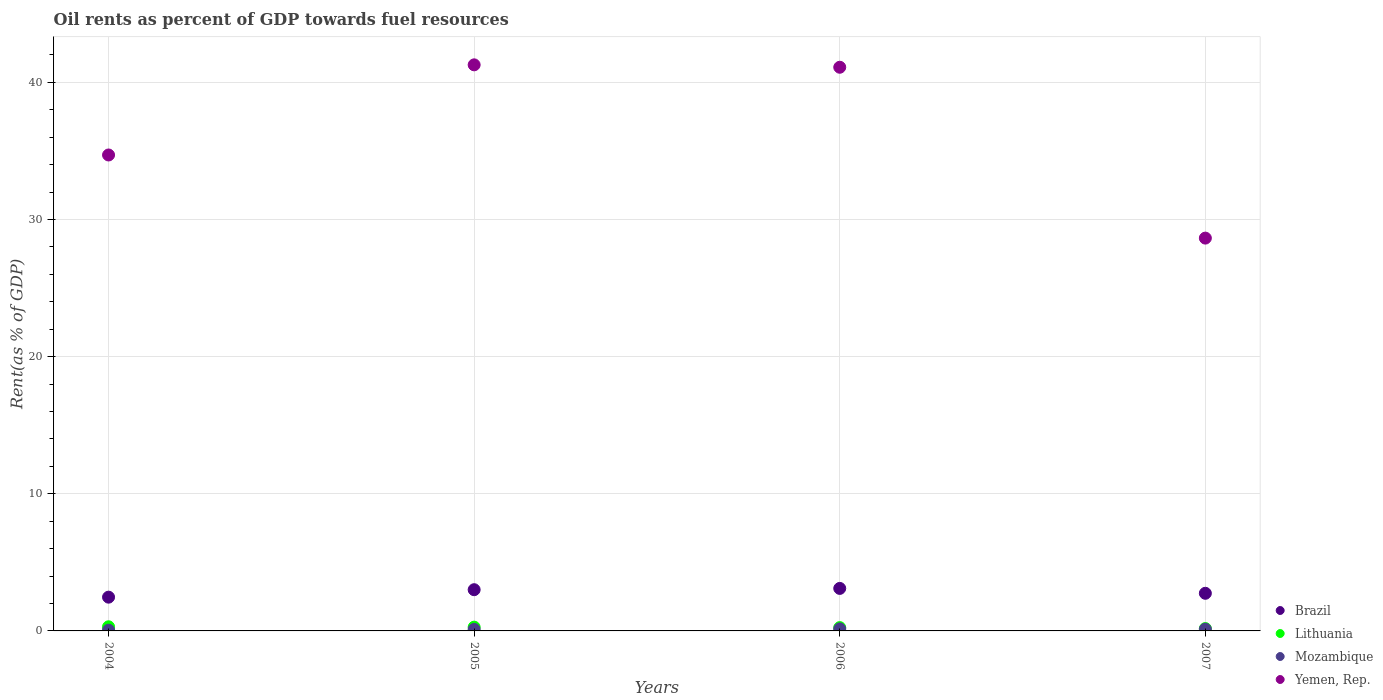How many different coloured dotlines are there?
Offer a terse response. 4. What is the oil rent in Mozambique in 2005?
Your answer should be compact. 0.11. Across all years, what is the maximum oil rent in Lithuania?
Offer a terse response. 0.3. Across all years, what is the minimum oil rent in Brazil?
Give a very brief answer. 2.46. In which year was the oil rent in Lithuania minimum?
Offer a very short reply. 2007. What is the total oil rent in Yemen, Rep. in the graph?
Offer a terse response. 145.74. What is the difference between the oil rent in Lithuania in 2006 and that in 2007?
Provide a short and direct response. 0.07. What is the difference between the oil rent in Mozambique in 2004 and the oil rent in Lithuania in 2007?
Give a very brief answer. -0.12. What is the average oil rent in Brazil per year?
Keep it short and to the point. 2.83. In the year 2005, what is the difference between the oil rent in Lithuania and oil rent in Brazil?
Your answer should be very brief. -2.73. In how many years, is the oil rent in Yemen, Rep. greater than 30 %?
Your answer should be very brief. 3. What is the ratio of the oil rent in Yemen, Rep. in 2005 to that in 2007?
Offer a terse response. 1.44. Is the oil rent in Lithuania in 2005 less than that in 2007?
Keep it short and to the point. No. Is the difference between the oil rent in Lithuania in 2005 and 2006 greater than the difference between the oil rent in Brazil in 2005 and 2006?
Offer a very short reply. Yes. What is the difference between the highest and the second highest oil rent in Brazil?
Keep it short and to the point. 0.09. What is the difference between the highest and the lowest oil rent in Lithuania?
Your response must be concise. 0.13. Does the oil rent in Lithuania monotonically increase over the years?
Provide a succinct answer. No. Is the oil rent in Mozambique strictly greater than the oil rent in Yemen, Rep. over the years?
Offer a terse response. No. Is the oil rent in Yemen, Rep. strictly less than the oil rent in Mozambique over the years?
Provide a short and direct response. No. What is the difference between two consecutive major ticks on the Y-axis?
Give a very brief answer. 10. Are the values on the major ticks of Y-axis written in scientific E-notation?
Offer a very short reply. No. Does the graph contain grids?
Your response must be concise. Yes. How many legend labels are there?
Offer a terse response. 4. What is the title of the graph?
Offer a very short reply. Oil rents as percent of GDP towards fuel resources. What is the label or title of the X-axis?
Make the answer very short. Years. What is the label or title of the Y-axis?
Your answer should be compact. Rent(as % of GDP). What is the Rent(as % of GDP) of Brazil in 2004?
Provide a succinct answer. 2.46. What is the Rent(as % of GDP) of Lithuania in 2004?
Your answer should be very brief. 0.3. What is the Rent(as % of GDP) of Mozambique in 2004?
Offer a very short reply. 0.05. What is the Rent(as % of GDP) in Yemen, Rep. in 2004?
Ensure brevity in your answer.  34.71. What is the Rent(as % of GDP) of Brazil in 2005?
Your response must be concise. 3.01. What is the Rent(as % of GDP) of Lithuania in 2005?
Keep it short and to the point. 0.28. What is the Rent(as % of GDP) in Mozambique in 2005?
Offer a terse response. 0.11. What is the Rent(as % of GDP) of Yemen, Rep. in 2005?
Ensure brevity in your answer.  41.28. What is the Rent(as % of GDP) of Brazil in 2006?
Offer a very short reply. 3.1. What is the Rent(as % of GDP) of Lithuania in 2006?
Offer a terse response. 0.24. What is the Rent(as % of GDP) in Mozambique in 2006?
Your answer should be compact. 0.15. What is the Rent(as % of GDP) in Yemen, Rep. in 2006?
Your response must be concise. 41.1. What is the Rent(as % of GDP) of Brazil in 2007?
Keep it short and to the point. 2.74. What is the Rent(as % of GDP) of Lithuania in 2007?
Make the answer very short. 0.17. What is the Rent(as % of GDP) in Mozambique in 2007?
Offer a very short reply. 0.13. What is the Rent(as % of GDP) in Yemen, Rep. in 2007?
Offer a very short reply. 28.65. Across all years, what is the maximum Rent(as % of GDP) of Brazil?
Provide a short and direct response. 3.1. Across all years, what is the maximum Rent(as % of GDP) in Lithuania?
Offer a terse response. 0.3. Across all years, what is the maximum Rent(as % of GDP) of Mozambique?
Give a very brief answer. 0.15. Across all years, what is the maximum Rent(as % of GDP) in Yemen, Rep.?
Give a very brief answer. 41.28. Across all years, what is the minimum Rent(as % of GDP) of Brazil?
Make the answer very short. 2.46. Across all years, what is the minimum Rent(as % of GDP) in Lithuania?
Your answer should be compact. 0.17. Across all years, what is the minimum Rent(as % of GDP) of Mozambique?
Provide a succinct answer. 0.05. Across all years, what is the minimum Rent(as % of GDP) of Yemen, Rep.?
Provide a short and direct response. 28.65. What is the total Rent(as % of GDP) of Brazil in the graph?
Ensure brevity in your answer.  11.31. What is the total Rent(as % of GDP) of Mozambique in the graph?
Your response must be concise. 0.44. What is the total Rent(as % of GDP) in Yemen, Rep. in the graph?
Offer a terse response. 145.74. What is the difference between the Rent(as % of GDP) of Brazil in 2004 and that in 2005?
Your answer should be compact. -0.54. What is the difference between the Rent(as % of GDP) in Lithuania in 2004 and that in 2005?
Give a very brief answer. 0.03. What is the difference between the Rent(as % of GDP) of Mozambique in 2004 and that in 2005?
Provide a succinct answer. -0.06. What is the difference between the Rent(as % of GDP) in Yemen, Rep. in 2004 and that in 2005?
Your answer should be compact. -6.57. What is the difference between the Rent(as % of GDP) in Brazil in 2004 and that in 2006?
Your answer should be compact. -0.64. What is the difference between the Rent(as % of GDP) of Lithuania in 2004 and that in 2006?
Your response must be concise. 0.06. What is the difference between the Rent(as % of GDP) in Mozambique in 2004 and that in 2006?
Your answer should be compact. -0.09. What is the difference between the Rent(as % of GDP) in Yemen, Rep. in 2004 and that in 2006?
Ensure brevity in your answer.  -6.4. What is the difference between the Rent(as % of GDP) in Brazil in 2004 and that in 2007?
Keep it short and to the point. -0.28. What is the difference between the Rent(as % of GDP) in Lithuania in 2004 and that in 2007?
Your answer should be compact. 0.13. What is the difference between the Rent(as % of GDP) in Mozambique in 2004 and that in 2007?
Your answer should be compact. -0.07. What is the difference between the Rent(as % of GDP) in Yemen, Rep. in 2004 and that in 2007?
Keep it short and to the point. 6.06. What is the difference between the Rent(as % of GDP) in Brazil in 2005 and that in 2006?
Give a very brief answer. -0.09. What is the difference between the Rent(as % of GDP) in Lithuania in 2005 and that in 2006?
Make the answer very short. 0.03. What is the difference between the Rent(as % of GDP) of Mozambique in 2005 and that in 2006?
Give a very brief answer. -0.04. What is the difference between the Rent(as % of GDP) of Yemen, Rep. in 2005 and that in 2006?
Your answer should be very brief. 0.18. What is the difference between the Rent(as % of GDP) of Brazil in 2005 and that in 2007?
Offer a terse response. 0.26. What is the difference between the Rent(as % of GDP) of Lithuania in 2005 and that in 2007?
Offer a terse response. 0.1. What is the difference between the Rent(as % of GDP) in Mozambique in 2005 and that in 2007?
Keep it short and to the point. -0.02. What is the difference between the Rent(as % of GDP) in Yemen, Rep. in 2005 and that in 2007?
Give a very brief answer. 12.64. What is the difference between the Rent(as % of GDP) of Brazil in 2006 and that in 2007?
Offer a very short reply. 0.36. What is the difference between the Rent(as % of GDP) in Lithuania in 2006 and that in 2007?
Ensure brevity in your answer.  0.07. What is the difference between the Rent(as % of GDP) in Mozambique in 2006 and that in 2007?
Give a very brief answer. 0.02. What is the difference between the Rent(as % of GDP) of Yemen, Rep. in 2006 and that in 2007?
Provide a succinct answer. 12.46. What is the difference between the Rent(as % of GDP) in Brazil in 2004 and the Rent(as % of GDP) in Lithuania in 2005?
Offer a very short reply. 2.19. What is the difference between the Rent(as % of GDP) in Brazil in 2004 and the Rent(as % of GDP) in Mozambique in 2005?
Your answer should be compact. 2.35. What is the difference between the Rent(as % of GDP) of Brazil in 2004 and the Rent(as % of GDP) of Yemen, Rep. in 2005?
Your answer should be very brief. -38.82. What is the difference between the Rent(as % of GDP) in Lithuania in 2004 and the Rent(as % of GDP) in Mozambique in 2005?
Provide a short and direct response. 0.19. What is the difference between the Rent(as % of GDP) in Lithuania in 2004 and the Rent(as % of GDP) in Yemen, Rep. in 2005?
Your response must be concise. -40.98. What is the difference between the Rent(as % of GDP) in Mozambique in 2004 and the Rent(as % of GDP) in Yemen, Rep. in 2005?
Give a very brief answer. -41.23. What is the difference between the Rent(as % of GDP) of Brazil in 2004 and the Rent(as % of GDP) of Lithuania in 2006?
Your answer should be very brief. 2.22. What is the difference between the Rent(as % of GDP) in Brazil in 2004 and the Rent(as % of GDP) in Mozambique in 2006?
Your answer should be very brief. 2.31. What is the difference between the Rent(as % of GDP) in Brazil in 2004 and the Rent(as % of GDP) in Yemen, Rep. in 2006?
Your answer should be very brief. -38.64. What is the difference between the Rent(as % of GDP) in Lithuania in 2004 and the Rent(as % of GDP) in Mozambique in 2006?
Provide a succinct answer. 0.15. What is the difference between the Rent(as % of GDP) in Lithuania in 2004 and the Rent(as % of GDP) in Yemen, Rep. in 2006?
Your answer should be compact. -40.8. What is the difference between the Rent(as % of GDP) in Mozambique in 2004 and the Rent(as % of GDP) in Yemen, Rep. in 2006?
Offer a very short reply. -41.05. What is the difference between the Rent(as % of GDP) in Brazil in 2004 and the Rent(as % of GDP) in Lithuania in 2007?
Make the answer very short. 2.29. What is the difference between the Rent(as % of GDP) in Brazil in 2004 and the Rent(as % of GDP) in Mozambique in 2007?
Your response must be concise. 2.34. What is the difference between the Rent(as % of GDP) in Brazil in 2004 and the Rent(as % of GDP) in Yemen, Rep. in 2007?
Your response must be concise. -26.18. What is the difference between the Rent(as % of GDP) of Lithuania in 2004 and the Rent(as % of GDP) of Mozambique in 2007?
Offer a terse response. 0.18. What is the difference between the Rent(as % of GDP) of Lithuania in 2004 and the Rent(as % of GDP) of Yemen, Rep. in 2007?
Make the answer very short. -28.34. What is the difference between the Rent(as % of GDP) in Mozambique in 2004 and the Rent(as % of GDP) in Yemen, Rep. in 2007?
Make the answer very short. -28.59. What is the difference between the Rent(as % of GDP) in Brazil in 2005 and the Rent(as % of GDP) in Lithuania in 2006?
Keep it short and to the point. 2.76. What is the difference between the Rent(as % of GDP) of Brazil in 2005 and the Rent(as % of GDP) of Mozambique in 2006?
Give a very brief answer. 2.86. What is the difference between the Rent(as % of GDP) in Brazil in 2005 and the Rent(as % of GDP) in Yemen, Rep. in 2006?
Provide a short and direct response. -38.1. What is the difference between the Rent(as % of GDP) in Lithuania in 2005 and the Rent(as % of GDP) in Mozambique in 2006?
Ensure brevity in your answer.  0.13. What is the difference between the Rent(as % of GDP) in Lithuania in 2005 and the Rent(as % of GDP) in Yemen, Rep. in 2006?
Provide a succinct answer. -40.83. What is the difference between the Rent(as % of GDP) in Mozambique in 2005 and the Rent(as % of GDP) in Yemen, Rep. in 2006?
Keep it short and to the point. -40.99. What is the difference between the Rent(as % of GDP) in Brazil in 2005 and the Rent(as % of GDP) in Lithuania in 2007?
Your answer should be compact. 2.83. What is the difference between the Rent(as % of GDP) in Brazil in 2005 and the Rent(as % of GDP) in Mozambique in 2007?
Your answer should be compact. 2.88. What is the difference between the Rent(as % of GDP) of Brazil in 2005 and the Rent(as % of GDP) of Yemen, Rep. in 2007?
Offer a terse response. -25.64. What is the difference between the Rent(as % of GDP) of Lithuania in 2005 and the Rent(as % of GDP) of Mozambique in 2007?
Your answer should be compact. 0.15. What is the difference between the Rent(as % of GDP) of Lithuania in 2005 and the Rent(as % of GDP) of Yemen, Rep. in 2007?
Your response must be concise. -28.37. What is the difference between the Rent(as % of GDP) in Mozambique in 2005 and the Rent(as % of GDP) in Yemen, Rep. in 2007?
Keep it short and to the point. -28.53. What is the difference between the Rent(as % of GDP) in Brazil in 2006 and the Rent(as % of GDP) in Lithuania in 2007?
Keep it short and to the point. 2.93. What is the difference between the Rent(as % of GDP) of Brazil in 2006 and the Rent(as % of GDP) of Mozambique in 2007?
Make the answer very short. 2.97. What is the difference between the Rent(as % of GDP) of Brazil in 2006 and the Rent(as % of GDP) of Yemen, Rep. in 2007?
Your answer should be very brief. -25.55. What is the difference between the Rent(as % of GDP) of Lithuania in 2006 and the Rent(as % of GDP) of Mozambique in 2007?
Make the answer very short. 0.12. What is the difference between the Rent(as % of GDP) of Lithuania in 2006 and the Rent(as % of GDP) of Yemen, Rep. in 2007?
Your answer should be compact. -28.4. What is the difference between the Rent(as % of GDP) in Mozambique in 2006 and the Rent(as % of GDP) in Yemen, Rep. in 2007?
Make the answer very short. -28.5. What is the average Rent(as % of GDP) of Brazil per year?
Offer a very short reply. 2.83. What is the average Rent(as % of GDP) of Lithuania per year?
Provide a short and direct response. 0.25. What is the average Rent(as % of GDP) in Mozambique per year?
Offer a terse response. 0.11. What is the average Rent(as % of GDP) in Yemen, Rep. per year?
Ensure brevity in your answer.  36.43. In the year 2004, what is the difference between the Rent(as % of GDP) in Brazil and Rent(as % of GDP) in Lithuania?
Provide a short and direct response. 2.16. In the year 2004, what is the difference between the Rent(as % of GDP) of Brazil and Rent(as % of GDP) of Mozambique?
Offer a terse response. 2.41. In the year 2004, what is the difference between the Rent(as % of GDP) in Brazil and Rent(as % of GDP) in Yemen, Rep.?
Provide a short and direct response. -32.24. In the year 2004, what is the difference between the Rent(as % of GDP) in Lithuania and Rent(as % of GDP) in Mozambique?
Ensure brevity in your answer.  0.25. In the year 2004, what is the difference between the Rent(as % of GDP) of Lithuania and Rent(as % of GDP) of Yemen, Rep.?
Keep it short and to the point. -34.4. In the year 2004, what is the difference between the Rent(as % of GDP) of Mozambique and Rent(as % of GDP) of Yemen, Rep.?
Your response must be concise. -34.65. In the year 2005, what is the difference between the Rent(as % of GDP) in Brazil and Rent(as % of GDP) in Lithuania?
Provide a succinct answer. 2.73. In the year 2005, what is the difference between the Rent(as % of GDP) in Brazil and Rent(as % of GDP) in Mozambique?
Your answer should be very brief. 2.9. In the year 2005, what is the difference between the Rent(as % of GDP) in Brazil and Rent(as % of GDP) in Yemen, Rep.?
Your answer should be very brief. -38.27. In the year 2005, what is the difference between the Rent(as % of GDP) in Lithuania and Rent(as % of GDP) in Mozambique?
Make the answer very short. 0.16. In the year 2005, what is the difference between the Rent(as % of GDP) of Lithuania and Rent(as % of GDP) of Yemen, Rep.?
Provide a succinct answer. -41.01. In the year 2005, what is the difference between the Rent(as % of GDP) in Mozambique and Rent(as % of GDP) in Yemen, Rep.?
Your response must be concise. -41.17. In the year 2006, what is the difference between the Rent(as % of GDP) of Brazil and Rent(as % of GDP) of Lithuania?
Your answer should be very brief. 2.86. In the year 2006, what is the difference between the Rent(as % of GDP) of Brazil and Rent(as % of GDP) of Mozambique?
Your response must be concise. 2.95. In the year 2006, what is the difference between the Rent(as % of GDP) in Brazil and Rent(as % of GDP) in Yemen, Rep.?
Keep it short and to the point. -38. In the year 2006, what is the difference between the Rent(as % of GDP) of Lithuania and Rent(as % of GDP) of Mozambique?
Provide a succinct answer. 0.09. In the year 2006, what is the difference between the Rent(as % of GDP) of Lithuania and Rent(as % of GDP) of Yemen, Rep.?
Keep it short and to the point. -40.86. In the year 2006, what is the difference between the Rent(as % of GDP) in Mozambique and Rent(as % of GDP) in Yemen, Rep.?
Provide a short and direct response. -40.96. In the year 2007, what is the difference between the Rent(as % of GDP) in Brazil and Rent(as % of GDP) in Lithuania?
Provide a succinct answer. 2.57. In the year 2007, what is the difference between the Rent(as % of GDP) in Brazil and Rent(as % of GDP) in Mozambique?
Your answer should be compact. 2.62. In the year 2007, what is the difference between the Rent(as % of GDP) of Brazil and Rent(as % of GDP) of Yemen, Rep.?
Give a very brief answer. -25.9. In the year 2007, what is the difference between the Rent(as % of GDP) of Lithuania and Rent(as % of GDP) of Mozambique?
Offer a very short reply. 0.05. In the year 2007, what is the difference between the Rent(as % of GDP) in Lithuania and Rent(as % of GDP) in Yemen, Rep.?
Provide a short and direct response. -28.47. In the year 2007, what is the difference between the Rent(as % of GDP) of Mozambique and Rent(as % of GDP) of Yemen, Rep.?
Your response must be concise. -28.52. What is the ratio of the Rent(as % of GDP) of Brazil in 2004 to that in 2005?
Provide a short and direct response. 0.82. What is the ratio of the Rent(as % of GDP) of Lithuania in 2004 to that in 2005?
Ensure brevity in your answer.  1.1. What is the ratio of the Rent(as % of GDP) in Mozambique in 2004 to that in 2005?
Make the answer very short. 0.49. What is the ratio of the Rent(as % of GDP) in Yemen, Rep. in 2004 to that in 2005?
Offer a very short reply. 0.84. What is the ratio of the Rent(as % of GDP) in Brazil in 2004 to that in 2006?
Your answer should be very brief. 0.79. What is the ratio of the Rent(as % of GDP) of Lithuania in 2004 to that in 2006?
Provide a succinct answer. 1.25. What is the ratio of the Rent(as % of GDP) of Mozambique in 2004 to that in 2006?
Make the answer very short. 0.37. What is the ratio of the Rent(as % of GDP) of Yemen, Rep. in 2004 to that in 2006?
Your response must be concise. 0.84. What is the ratio of the Rent(as % of GDP) in Brazil in 2004 to that in 2007?
Make the answer very short. 0.9. What is the ratio of the Rent(as % of GDP) in Lithuania in 2004 to that in 2007?
Keep it short and to the point. 1.76. What is the ratio of the Rent(as % of GDP) in Mozambique in 2004 to that in 2007?
Provide a short and direct response. 0.43. What is the ratio of the Rent(as % of GDP) in Yemen, Rep. in 2004 to that in 2007?
Your answer should be compact. 1.21. What is the ratio of the Rent(as % of GDP) of Brazil in 2005 to that in 2006?
Your answer should be very brief. 0.97. What is the ratio of the Rent(as % of GDP) of Lithuania in 2005 to that in 2006?
Ensure brevity in your answer.  1.14. What is the ratio of the Rent(as % of GDP) of Mozambique in 2005 to that in 2006?
Provide a succinct answer. 0.75. What is the ratio of the Rent(as % of GDP) in Brazil in 2005 to that in 2007?
Offer a terse response. 1.1. What is the ratio of the Rent(as % of GDP) of Lithuania in 2005 to that in 2007?
Keep it short and to the point. 1.6. What is the ratio of the Rent(as % of GDP) in Mozambique in 2005 to that in 2007?
Provide a short and direct response. 0.87. What is the ratio of the Rent(as % of GDP) of Yemen, Rep. in 2005 to that in 2007?
Give a very brief answer. 1.44. What is the ratio of the Rent(as % of GDP) of Brazil in 2006 to that in 2007?
Your answer should be very brief. 1.13. What is the ratio of the Rent(as % of GDP) of Lithuania in 2006 to that in 2007?
Offer a terse response. 1.41. What is the ratio of the Rent(as % of GDP) in Mozambique in 2006 to that in 2007?
Offer a very short reply. 1.17. What is the ratio of the Rent(as % of GDP) of Yemen, Rep. in 2006 to that in 2007?
Offer a very short reply. 1.43. What is the difference between the highest and the second highest Rent(as % of GDP) in Brazil?
Your answer should be compact. 0.09. What is the difference between the highest and the second highest Rent(as % of GDP) of Lithuania?
Provide a succinct answer. 0.03. What is the difference between the highest and the second highest Rent(as % of GDP) in Mozambique?
Your answer should be very brief. 0.02. What is the difference between the highest and the second highest Rent(as % of GDP) in Yemen, Rep.?
Give a very brief answer. 0.18. What is the difference between the highest and the lowest Rent(as % of GDP) of Brazil?
Keep it short and to the point. 0.64. What is the difference between the highest and the lowest Rent(as % of GDP) in Lithuania?
Offer a very short reply. 0.13. What is the difference between the highest and the lowest Rent(as % of GDP) of Mozambique?
Ensure brevity in your answer.  0.09. What is the difference between the highest and the lowest Rent(as % of GDP) of Yemen, Rep.?
Offer a terse response. 12.64. 